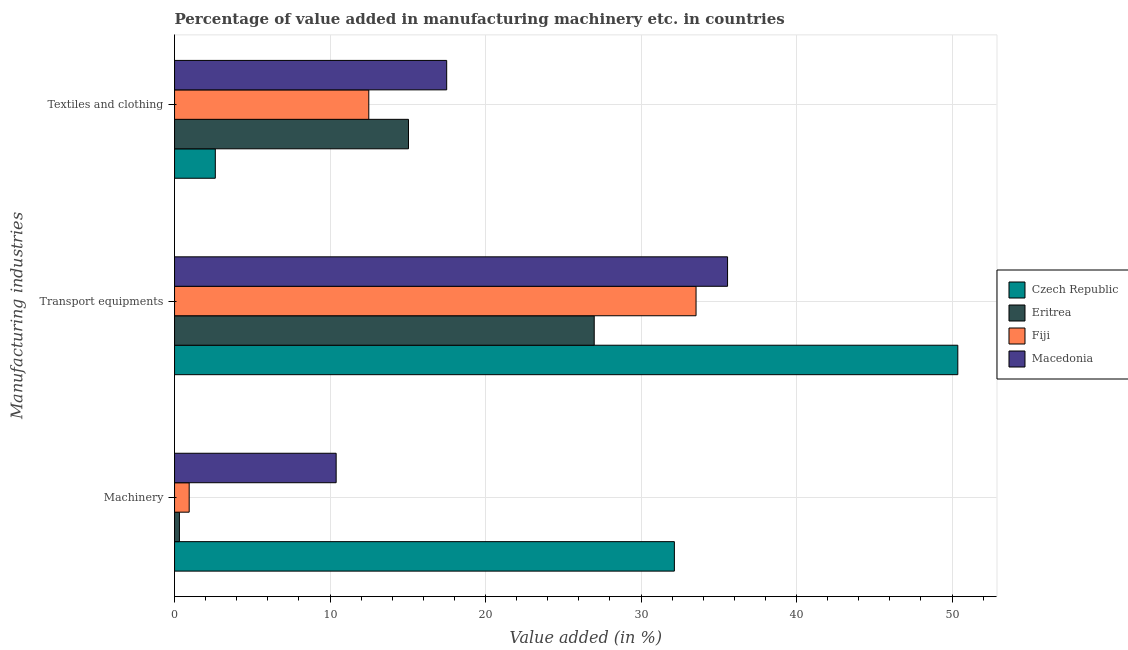How many different coloured bars are there?
Your response must be concise. 4. Are the number of bars on each tick of the Y-axis equal?
Provide a short and direct response. Yes. What is the label of the 1st group of bars from the top?
Provide a short and direct response. Textiles and clothing. What is the value added in manufacturing textile and clothing in Czech Republic?
Your answer should be compact. 2.62. Across all countries, what is the maximum value added in manufacturing machinery?
Your response must be concise. 32.14. Across all countries, what is the minimum value added in manufacturing transport equipments?
Your response must be concise. 26.99. In which country was the value added in manufacturing machinery maximum?
Offer a terse response. Czech Republic. In which country was the value added in manufacturing machinery minimum?
Offer a terse response. Eritrea. What is the total value added in manufacturing machinery in the graph?
Provide a short and direct response. 43.79. What is the difference between the value added in manufacturing transport equipments in Eritrea and that in Macedonia?
Your response must be concise. -8.57. What is the difference between the value added in manufacturing machinery in Czech Republic and the value added in manufacturing textile and clothing in Fiji?
Offer a terse response. 19.65. What is the average value added in manufacturing machinery per country?
Keep it short and to the point. 10.95. What is the difference between the value added in manufacturing machinery and value added in manufacturing textile and clothing in Eritrea?
Offer a very short reply. -14.73. What is the ratio of the value added in manufacturing textile and clothing in Macedonia to that in Fiji?
Your answer should be compact. 1.4. What is the difference between the highest and the second highest value added in manufacturing machinery?
Give a very brief answer. 21.75. What is the difference between the highest and the lowest value added in manufacturing machinery?
Offer a terse response. 31.83. In how many countries, is the value added in manufacturing machinery greater than the average value added in manufacturing machinery taken over all countries?
Provide a succinct answer. 1. What does the 1st bar from the top in Machinery represents?
Keep it short and to the point. Macedonia. What does the 1st bar from the bottom in Transport equipments represents?
Your answer should be compact. Czech Republic. Is it the case that in every country, the sum of the value added in manufacturing machinery and value added in manufacturing transport equipments is greater than the value added in manufacturing textile and clothing?
Make the answer very short. Yes. How many bars are there?
Offer a very short reply. 12. What is the difference between two consecutive major ticks on the X-axis?
Give a very brief answer. 10. Does the graph contain grids?
Ensure brevity in your answer.  Yes. How many legend labels are there?
Your answer should be very brief. 4. What is the title of the graph?
Give a very brief answer. Percentage of value added in manufacturing machinery etc. in countries. What is the label or title of the X-axis?
Your answer should be very brief. Value added (in %). What is the label or title of the Y-axis?
Provide a short and direct response. Manufacturing industries. What is the Value added (in %) in Czech Republic in Machinery?
Offer a very short reply. 32.14. What is the Value added (in %) of Eritrea in Machinery?
Your answer should be very brief. 0.31. What is the Value added (in %) in Fiji in Machinery?
Offer a terse response. 0.94. What is the Value added (in %) of Macedonia in Machinery?
Give a very brief answer. 10.39. What is the Value added (in %) in Czech Republic in Transport equipments?
Provide a short and direct response. 50.37. What is the Value added (in %) in Eritrea in Transport equipments?
Keep it short and to the point. 26.99. What is the Value added (in %) of Fiji in Transport equipments?
Your response must be concise. 33.53. What is the Value added (in %) of Macedonia in Transport equipments?
Make the answer very short. 35.56. What is the Value added (in %) in Czech Republic in Textiles and clothing?
Your answer should be compact. 2.62. What is the Value added (in %) in Eritrea in Textiles and clothing?
Offer a very short reply. 15.04. What is the Value added (in %) of Fiji in Textiles and clothing?
Provide a short and direct response. 12.49. What is the Value added (in %) in Macedonia in Textiles and clothing?
Provide a short and direct response. 17.5. Across all Manufacturing industries, what is the maximum Value added (in %) of Czech Republic?
Offer a terse response. 50.37. Across all Manufacturing industries, what is the maximum Value added (in %) in Eritrea?
Your answer should be very brief. 26.99. Across all Manufacturing industries, what is the maximum Value added (in %) of Fiji?
Ensure brevity in your answer.  33.53. Across all Manufacturing industries, what is the maximum Value added (in %) in Macedonia?
Your answer should be very brief. 35.56. Across all Manufacturing industries, what is the minimum Value added (in %) of Czech Republic?
Keep it short and to the point. 2.62. Across all Manufacturing industries, what is the minimum Value added (in %) of Eritrea?
Offer a terse response. 0.31. Across all Manufacturing industries, what is the minimum Value added (in %) of Fiji?
Offer a terse response. 0.94. Across all Manufacturing industries, what is the minimum Value added (in %) of Macedonia?
Provide a succinct answer. 10.39. What is the total Value added (in %) of Czech Republic in the graph?
Your answer should be compact. 85.13. What is the total Value added (in %) in Eritrea in the graph?
Offer a very short reply. 42.34. What is the total Value added (in %) of Fiji in the graph?
Give a very brief answer. 46.97. What is the total Value added (in %) in Macedonia in the graph?
Make the answer very short. 63.45. What is the difference between the Value added (in %) of Czech Republic in Machinery and that in Transport equipments?
Your answer should be compact. -18.23. What is the difference between the Value added (in %) in Eritrea in Machinery and that in Transport equipments?
Make the answer very short. -26.67. What is the difference between the Value added (in %) in Fiji in Machinery and that in Transport equipments?
Provide a succinct answer. -32.59. What is the difference between the Value added (in %) of Macedonia in Machinery and that in Transport equipments?
Your answer should be very brief. -25.17. What is the difference between the Value added (in %) in Czech Republic in Machinery and that in Textiles and clothing?
Give a very brief answer. 29.52. What is the difference between the Value added (in %) in Eritrea in Machinery and that in Textiles and clothing?
Your answer should be very brief. -14.73. What is the difference between the Value added (in %) of Fiji in Machinery and that in Textiles and clothing?
Your response must be concise. -11.55. What is the difference between the Value added (in %) in Macedonia in Machinery and that in Textiles and clothing?
Provide a short and direct response. -7.11. What is the difference between the Value added (in %) in Czech Republic in Transport equipments and that in Textiles and clothing?
Offer a terse response. 47.75. What is the difference between the Value added (in %) of Eritrea in Transport equipments and that in Textiles and clothing?
Your answer should be very brief. 11.94. What is the difference between the Value added (in %) of Fiji in Transport equipments and that in Textiles and clothing?
Make the answer very short. 21.04. What is the difference between the Value added (in %) in Macedonia in Transport equipments and that in Textiles and clothing?
Provide a succinct answer. 18.06. What is the difference between the Value added (in %) of Czech Republic in Machinery and the Value added (in %) of Eritrea in Transport equipments?
Give a very brief answer. 5.15. What is the difference between the Value added (in %) in Czech Republic in Machinery and the Value added (in %) in Fiji in Transport equipments?
Provide a succinct answer. -1.39. What is the difference between the Value added (in %) in Czech Republic in Machinery and the Value added (in %) in Macedonia in Transport equipments?
Your answer should be very brief. -3.42. What is the difference between the Value added (in %) of Eritrea in Machinery and the Value added (in %) of Fiji in Transport equipments?
Provide a short and direct response. -33.22. What is the difference between the Value added (in %) of Eritrea in Machinery and the Value added (in %) of Macedonia in Transport equipments?
Your response must be concise. -35.25. What is the difference between the Value added (in %) of Fiji in Machinery and the Value added (in %) of Macedonia in Transport equipments?
Give a very brief answer. -34.62. What is the difference between the Value added (in %) in Czech Republic in Machinery and the Value added (in %) in Eritrea in Textiles and clothing?
Your answer should be very brief. 17.1. What is the difference between the Value added (in %) in Czech Republic in Machinery and the Value added (in %) in Fiji in Textiles and clothing?
Ensure brevity in your answer.  19.65. What is the difference between the Value added (in %) in Czech Republic in Machinery and the Value added (in %) in Macedonia in Textiles and clothing?
Your response must be concise. 14.64. What is the difference between the Value added (in %) of Eritrea in Machinery and the Value added (in %) of Fiji in Textiles and clothing?
Provide a short and direct response. -12.18. What is the difference between the Value added (in %) of Eritrea in Machinery and the Value added (in %) of Macedonia in Textiles and clothing?
Offer a very short reply. -17.19. What is the difference between the Value added (in %) of Fiji in Machinery and the Value added (in %) of Macedonia in Textiles and clothing?
Your response must be concise. -16.56. What is the difference between the Value added (in %) of Czech Republic in Transport equipments and the Value added (in %) of Eritrea in Textiles and clothing?
Ensure brevity in your answer.  35.32. What is the difference between the Value added (in %) of Czech Republic in Transport equipments and the Value added (in %) of Fiji in Textiles and clothing?
Your response must be concise. 37.88. What is the difference between the Value added (in %) in Czech Republic in Transport equipments and the Value added (in %) in Macedonia in Textiles and clothing?
Your answer should be very brief. 32.87. What is the difference between the Value added (in %) in Eritrea in Transport equipments and the Value added (in %) in Fiji in Textiles and clothing?
Make the answer very short. 14.5. What is the difference between the Value added (in %) in Eritrea in Transport equipments and the Value added (in %) in Macedonia in Textiles and clothing?
Make the answer very short. 9.49. What is the difference between the Value added (in %) of Fiji in Transport equipments and the Value added (in %) of Macedonia in Textiles and clothing?
Give a very brief answer. 16.03. What is the average Value added (in %) in Czech Republic per Manufacturing industries?
Offer a very short reply. 28.38. What is the average Value added (in %) of Eritrea per Manufacturing industries?
Keep it short and to the point. 14.11. What is the average Value added (in %) in Fiji per Manufacturing industries?
Make the answer very short. 15.66. What is the average Value added (in %) in Macedonia per Manufacturing industries?
Your answer should be very brief. 21.15. What is the difference between the Value added (in %) in Czech Republic and Value added (in %) in Eritrea in Machinery?
Offer a very short reply. 31.83. What is the difference between the Value added (in %) in Czech Republic and Value added (in %) in Fiji in Machinery?
Make the answer very short. 31.2. What is the difference between the Value added (in %) of Czech Republic and Value added (in %) of Macedonia in Machinery?
Ensure brevity in your answer.  21.75. What is the difference between the Value added (in %) in Eritrea and Value added (in %) in Fiji in Machinery?
Ensure brevity in your answer.  -0.63. What is the difference between the Value added (in %) in Eritrea and Value added (in %) in Macedonia in Machinery?
Provide a succinct answer. -10.08. What is the difference between the Value added (in %) of Fiji and Value added (in %) of Macedonia in Machinery?
Offer a very short reply. -9.45. What is the difference between the Value added (in %) of Czech Republic and Value added (in %) of Eritrea in Transport equipments?
Provide a short and direct response. 23.38. What is the difference between the Value added (in %) in Czech Republic and Value added (in %) in Fiji in Transport equipments?
Ensure brevity in your answer.  16.83. What is the difference between the Value added (in %) in Czech Republic and Value added (in %) in Macedonia in Transport equipments?
Give a very brief answer. 14.81. What is the difference between the Value added (in %) in Eritrea and Value added (in %) in Fiji in Transport equipments?
Provide a short and direct response. -6.55. What is the difference between the Value added (in %) in Eritrea and Value added (in %) in Macedonia in Transport equipments?
Give a very brief answer. -8.57. What is the difference between the Value added (in %) of Fiji and Value added (in %) of Macedonia in Transport equipments?
Give a very brief answer. -2.03. What is the difference between the Value added (in %) of Czech Republic and Value added (in %) of Eritrea in Textiles and clothing?
Your answer should be very brief. -12.42. What is the difference between the Value added (in %) of Czech Republic and Value added (in %) of Fiji in Textiles and clothing?
Your answer should be very brief. -9.87. What is the difference between the Value added (in %) in Czech Republic and Value added (in %) in Macedonia in Textiles and clothing?
Provide a succinct answer. -14.88. What is the difference between the Value added (in %) in Eritrea and Value added (in %) in Fiji in Textiles and clothing?
Your answer should be compact. 2.55. What is the difference between the Value added (in %) in Eritrea and Value added (in %) in Macedonia in Textiles and clothing?
Make the answer very short. -2.46. What is the difference between the Value added (in %) of Fiji and Value added (in %) of Macedonia in Textiles and clothing?
Keep it short and to the point. -5.01. What is the ratio of the Value added (in %) in Czech Republic in Machinery to that in Transport equipments?
Provide a succinct answer. 0.64. What is the ratio of the Value added (in %) in Eritrea in Machinery to that in Transport equipments?
Your response must be concise. 0.01. What is the ratio of the Value added (in %) of Fiji in Machinery to that in Transport equipments?
Your response must be concise. 0.03. What is the ratio of the Value added (in %) in Macedonia in Machinery to that in Transport equipments?
Make the answer very short. 0.29. What is the ratio of the Value added (in %) in Czech Republic in Machinery to that in Textiles and clothing?
Your answer should be compact. 12.26. What is the ratio of the Value added (in %) of Eritrea in Machinery to that in Textiles and clothing?
Your answer should be very brief. 0.02. What is the ratio of the Value added (in %) of Fiji in Machinery to that in Textiles and clothing?
Ensure brevity in your answer.  0.08. What is the ratio of the Value added (in %) of Macedonia in Machinery to that in Textiles and clothing?
Provide a short and direct response. 0.59. What is the ratio of the Value added (in %) of Czech Republic in Transport equipments to that in Textiles and clothing?
Your response must be concise. 19.22. What is the ratio of the Value added (in %) in Eritrea in Transport equipments to that in Textiles and clothing?
Provide a short and direct response. 1.79. What is the ratio of the Value added (in %) in Fiji in Transport equipments to that in Textiles and clothing?
Make the answer very short. 2.68. What is the ratio of the Value added (in %) of Macedonia in Transport equipments to that in Textiles and clothing?
Ensure brevity in your answer.  2.03. What is the difference between the highest and the second highest Value added (in %) in Czech Republic?
Keep it short and to the point. 18.23. What is the difference between the highest and the second highest Value added (in %) of Eritrea?
Your answer should be very brief. 11.94. What is the difference between the highest and the second highest Value added (in %) in Fiji?
Give a very brief answer. 21.04. What is the difference between the highest and the second highest Value added (in %) in Macedonia?
Make the answer very short. 18.06. What is the difference between the highest and the lowest Value added (in %) of Czech Republic?
Give a very brief answer. 47.75. What is the difference between the highest and the lowest Value added (in %) of Eritrea?
Your answer should be compact. 26.67. What is the difference between the highest and the lowest Value added (in %) of Fiji?
Offer a terse response. 32.59. What is the difference between the highest and the lowest Value added (in %) in Macedonia?
Your response must be concise. 25.17. 